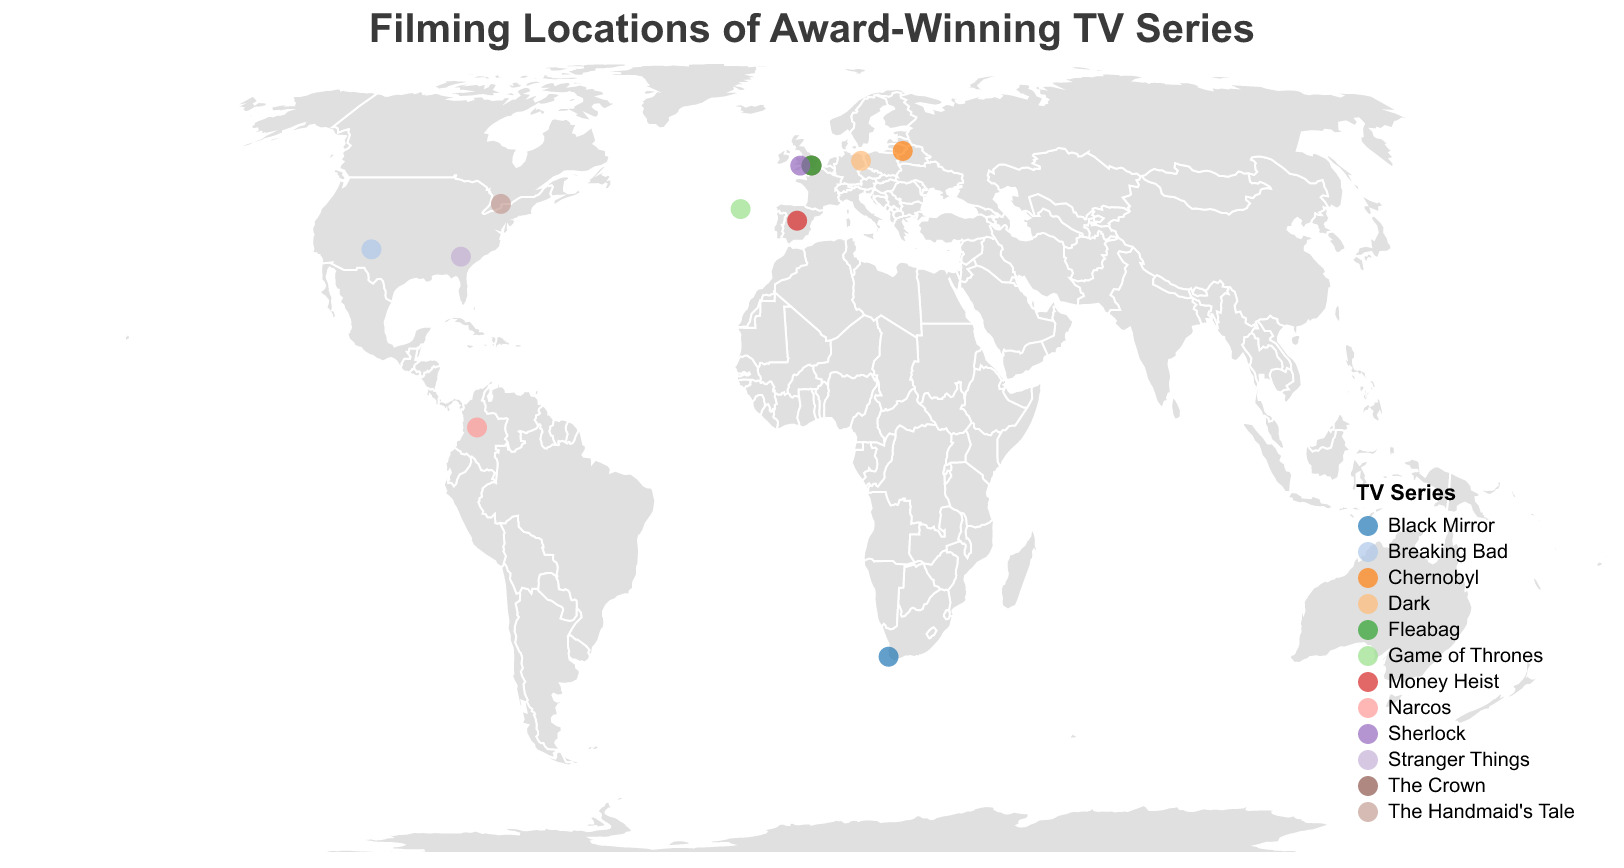What is the main title of the figure? The title of the figure is located at the top center, usually in a larger font size and bolder compared to other text elements. In this case, the title text is "Filming Locations of Award-Winning TV Series".
Answer: "Filming Locations of Award-Winning TV Series" How many TV series are represented on the plot? Each distinct color on the map represents a different TV series. By counting the number of unique colors or series names in the legend, we see there are 12 different TV series.
Answer: 12 Which TV series has the most awards, and where was it filmed? The figure's tooltip provides details on awards when you hover over each point. By scanning these tooltips, "Game of Thrones" has the most awards (38 Primetime Emmy Awards) and was filmed in Dubrovnik, Croatia.
Answer: "Game of Thrones" in Dubrovnik, Croatia Which continent has the highest number of filming locations for the listed TV series? By visually inspecting the number of points within each continent's boundary, Europe has the highest number of points (locations in Dubrovnik, London, Vilnius, Madrid, Berlin, and Cardiff).
Answer: Europe How many Primetime Emmy Awards has "Breaking Bad" received? Hovering over the point corresponding to "Breaking Bad" and reading the tooltip shows the series received 16 Primetime Emmy Awards.
Answer: 16 Which series has filming locations both in London UK and another city? By identifying points on the map, "The Crown" and "Fleabag" appear in London, UK, but only "The Crown" could have other connections (not directly confirmed in visible data but inferred by London multiple listings).
Answer: "The Crown" What filming location is positioned at the furthest south on the map? The lowest latitude on the map indicates the southernmost point. The point representing Cape Town, South Africa, corresponding to "Black Mirror", is at the latitude -33.9249.
Answer: Cape Town, South Africa Compare the total number of awards for series filmed in the UK versus the USA. Which is higher? Sum the awards: UK ("The Crown" 21, "Fleabag" 6, "Sherlock" 9) totals 36. USA ("Breaking Bad" 16, "Stranger Things" 6) totals 22. The UK total is higher.
Answer: UK What's the average latitude of filming locations for the UK TV series? Sum the latitudes of UK series locations (London 51.5074 twice, Cardiff 51.4816). Average: (51.5074 + 51.5074 + 51.4816) / 3 = 51.4988.
Answer: 51.4988 Are there more award-winning series filmed in the Northern Hemisphere or the Southern Hemisphere? Count points above and below the equator (latitude zero). All points except Cape Town, South Africa, are in the Northern Hemisphere. So, there are significantly more in the Northern Hemisphere.
Answer: Northern Hemisphere 